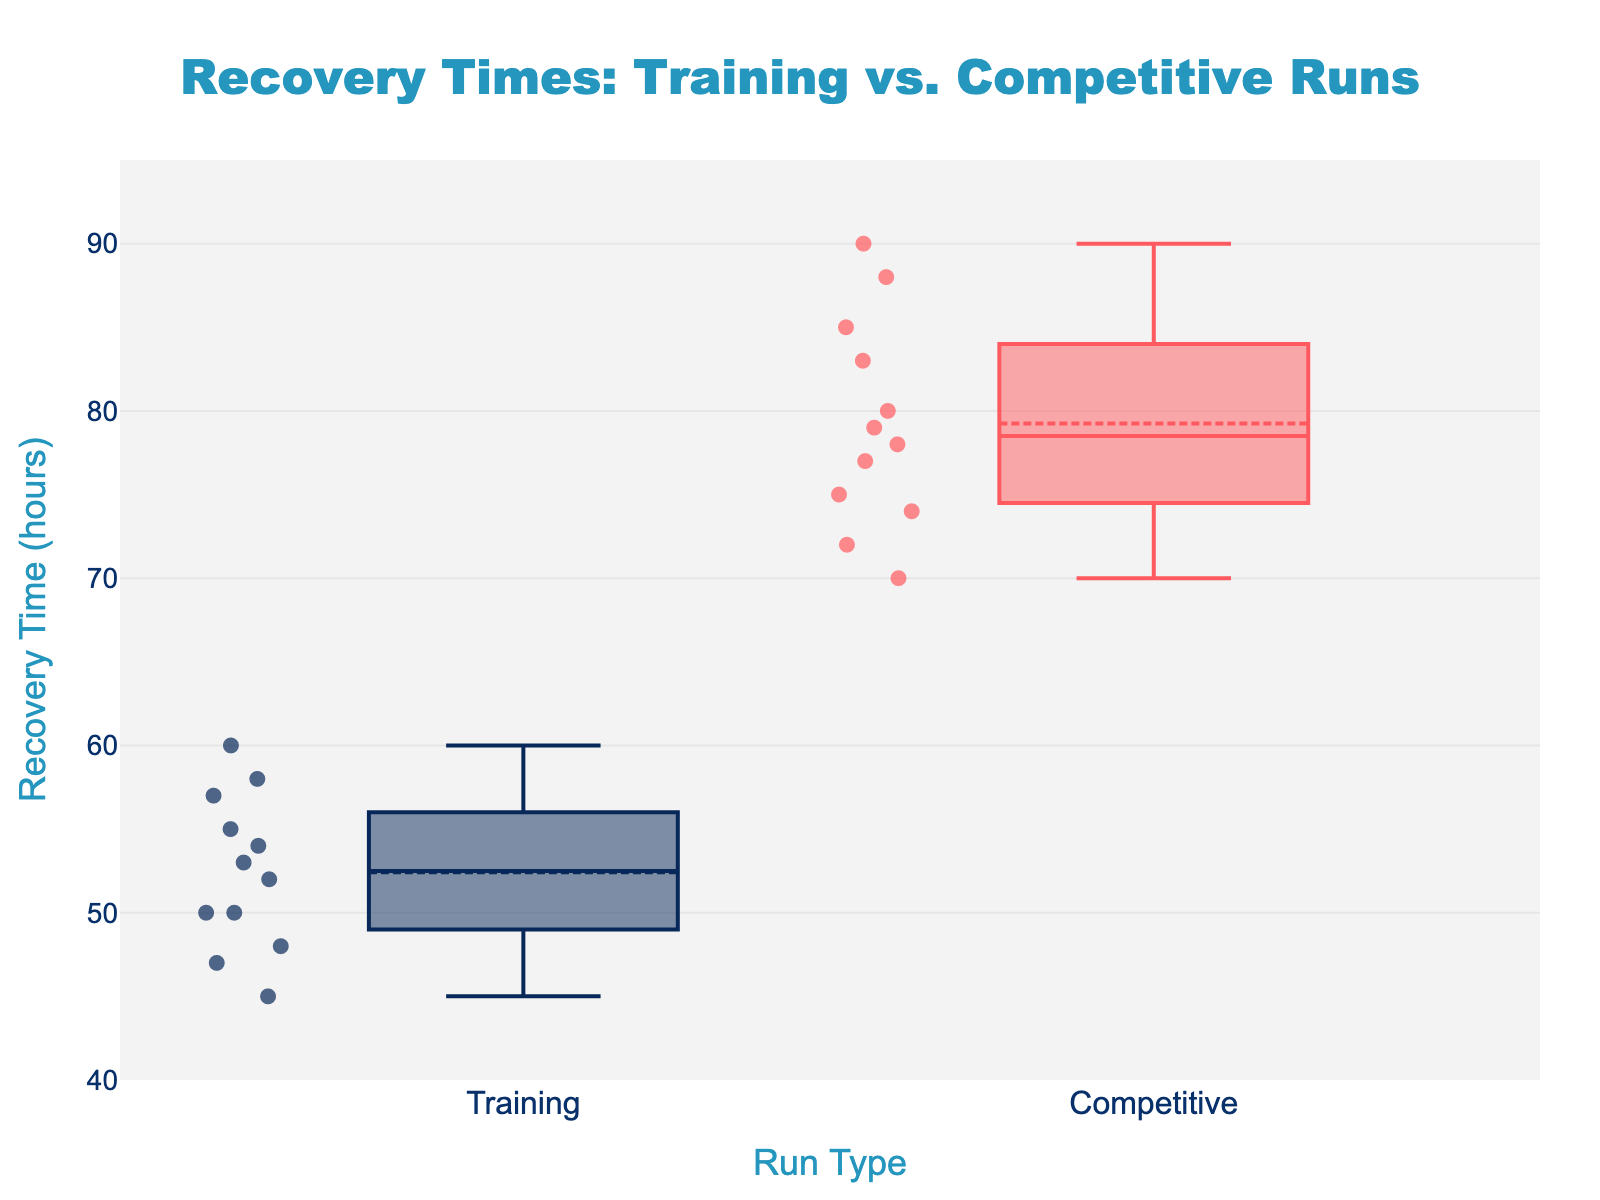What is the title of the figure? The title is displayed at the top of the figure. It is generally used to provide a summary or key information about the data presented.
Answer: Recovery Times: Training vs. Competitive Runs What are the run types compared in the figure? The run types are indicated on the x-axis under each box plot. There are two types compared, shown by the labels below the corresponding boxes.
Answer: Training and Competitive What is on the y-axis of this figure? The y-axis usually represents the variable being measured, which in this case is indicated by the y-axis title.
Answer: Recovery Time (hours) How many data points are there for the Training runs of Eliud Kipchoge? Each dot within the box plot represents an individual data point. By counting the number of dots, we can determine the number of data points.
Answer: 3 What is the median recovery time for Competitive runs? The median is represented by the line inside each box. For the competitive runs, this line indicates the median recovery time.
Answer: Approximately 80 hours Which type of run shows a wider range of recovery times? The range of recovery times can be identified by looking at the whiskers (lines extending from the boxes) and the spread of the data points.
Answer: Competitive runs Are there any outliers in the Training runs? Outliers would be indicated as points outside the whiskers of the box plot. By examining the training runs, we can check if any points fall outside this range.
Answer: No What is the average recovery time for Training runs of Mo Farah? To find the average, sum up the recovery times and divide by the number of data points. For Mo Farah, sum 52, 60, and 58, then divide by 3.
Answer: 56.67 hours How does the interquartile range (IQR) of Training runs compare to that of Competitive runs? The IQR is the range between the first quartile (bottom of the box) and the third quartile (top of the box). Comparing the height of the boxes will give the IQR.
Answer: The IQR is larger for Competitive runs What is the maximum recovery time for Competitive runs? The maximum recovery time can be found at the top of the whisker on the competitive box plot.
Answer: 90 hours 